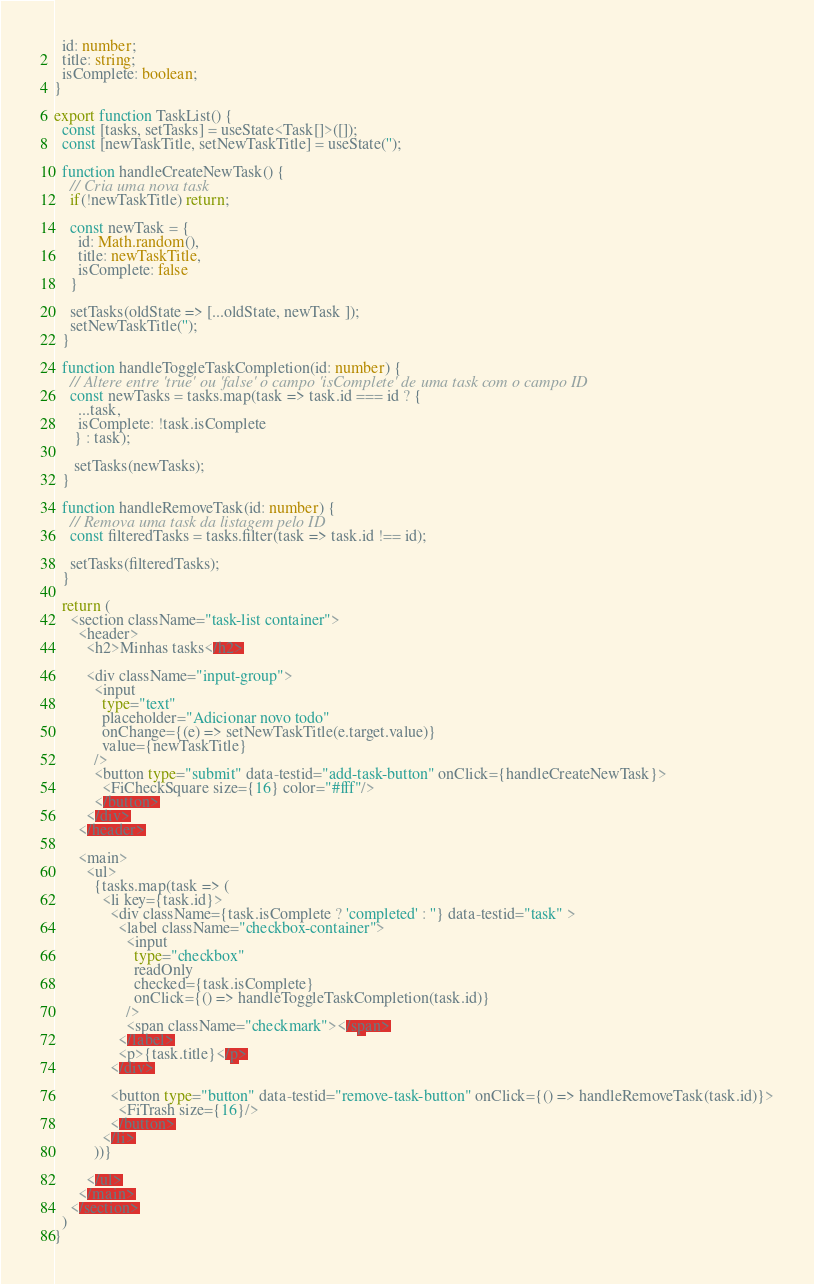Convert code to text. <code><loc_0><loc_0><loc_500><loc_500><_TypeScript_>  id: number;
  title: string;
  isComplete: boolean;
}

export function TaskList() {
  const [tasks, setTasks] = useState<Task[]>([]);
  const [newTaskTitle, setNewTaskTitle] = useState('');

  function handleCreateNewTask() {
    // Cria uma nova task 
    if(!newTaskTitle) return;

    const newTask = {
      id: Math.random(),
      title: newTaskTitle,
      isComplete: false
    }

    setTasks(oldState => [...oldState, newTask ]);
    setNewTaskTitle('');
  }

  function handleToggleTaskCompletion(id: number) {
    // Altere entre 'true' ou 'false' o campo 'isComplete' de uma task com o campo ID
    const newTasks = tasks.map(task => task.id === id ? {
      ...task,
      isComplete: !task.isComplete
     } : task);

     setTasks(newTasks);
  }

  function handleRemoveTask(id: number) {
    // Remova uma task da listagem pelo ID
    const filteredTasks = tasks.filter(task => task.id !== id);

    setTasks(filteredTasks);
  }

  return (
    <section className="task-list container">
      <header>
        <h2>Minhas tasks</h2>

        <div className="input-group">
          <input 
            type="text" 
            placeholder="Adicionar novo todo" 
            onChange={(e) => setNewTaskTitle(e.target.value)}
            value={newTaskTitle}
          />
          <button type="submit" data-testid="add-task-button" onClick={handleCreateNewTask}>
            <FiCheckSquare size={16} color="#fff"/>
          </button>
        </div>
      </header>

      <main>
        <ul>
          {tasks.map(task => (
            <li key={task.id}>
              <div className={task.isComplete ? 'completed' : ''} data-testid="task" >
                <label className="checkbox-container">
                  <input 
                    type="checkbox"
                    readOnly
                    checked={task.isComplete}
                    onClick={() => handleToggleTaskCompletion(task.id)}
                  />
                  <span className="checkmark"></span>
                </label>
                <p>{task.title}</p>
              </div>

              <button type="button" data-testid="remove-task-button" onClick={() => handleRemoveTask(task.id)}>
                <FiTrash size={16}/>
              </button>
            </li>
          ))}
          
        </ul>
      </main>
    </section>
  )
}</code> 